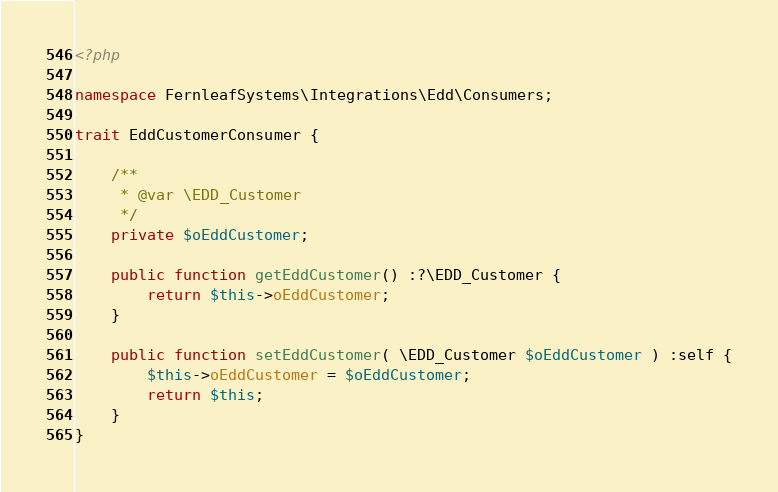Convert code to text. <code><loc_0><loc_0><loc_500><loc_500><_PHP_><?php

namespace FernleafSystems\Integrations\Edd\Consumers;

trait EddCustomerConsumer {

	/**
	 * @var \EDD_Customer
	 */
	private $oEddCustomer;

	public function getEddCustomer() :?\EDD_Customer {
		return $this->oEddCustomer;
	}

	public function setEddCustomer( \EDD_Customer $oEddCustomer ) :self {
		$this->oEddCustomer = $oEddCustomer;
		return $this;
	}
}</code> 